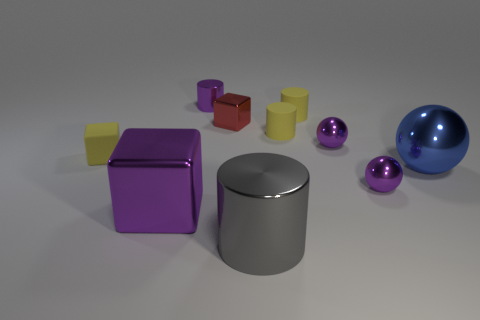Is the color of the large block the same as the small metallic cylinder?
Make the answer very short. Yes. Does the big gray thing have the same material as the big blue ball?
Provide a succinct answer. Yes. There is a large cube; what number of purple shiny balls are left of it?
Provide a succinct answer. 0. What size is the purple thing that is the same shape as the tiny red shiny object?
Keep it short and to the point. Large. What number of yellow things are either tiny shiny cubes or rubber objects?
Provide a succinct answer. 3. What number of tiny red metallic objects are behind the block that is in front of the big metal ball?
Your answer should be compact. 1. What number of other objects are the same shape as the big purple shiny thing?
Keep it short and to the point. 2. How many rubber objects have the same color as the small matte block?
Keep it short and to the point. 2. The tiny cube that is made of the same material as the tiny purple cylinder is what color?
Your answer should be very brief. Red. Is there a brown rubber block that has the same size as the gray thing?
Provide a succinct answer. No. 